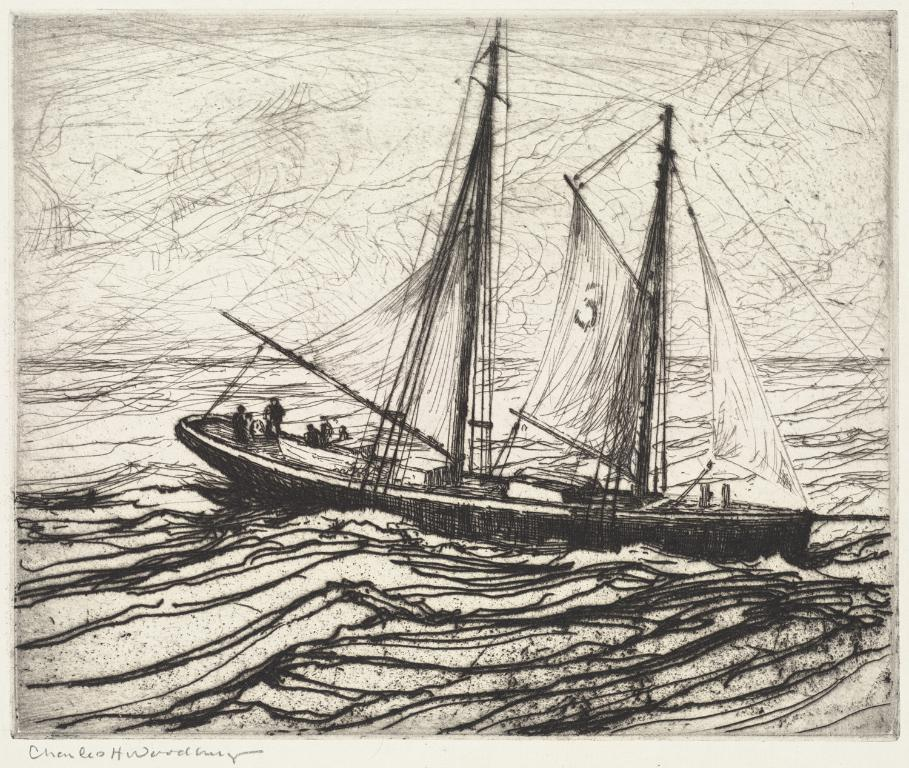What is depicted in the image? There is a drawing of a boat in the image. Where is the boat located? The boat is on the water. Are there any people in the image? Yes, there are people on the boat. What is present in the bottom left corner of the image? There is some text in the bottom left corner of the image. What type of sheet is covering the dog in the image? There is no dog present in the image, and therefore no sheet covering it. 